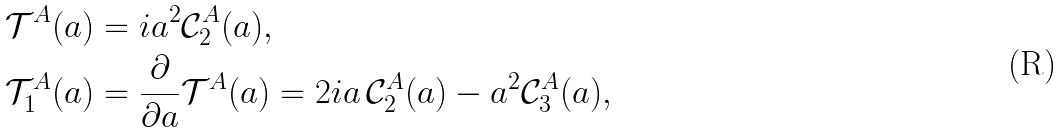Convert formula to latex. <formula><loc_0><loc_0><loc_500><loc_500>\mathcal { T } ^ { A } ( a ) & = i a ^ { 2 } \mathcal { C } _ { 2 } ^ { A } ( a ) , \\ \mathcal { T } ^ { A } _ { 1 } ( a ) & = \frac { \partial } { \partial a } \mathcal { T } ^ { A } ( a ) = 2 i a \, \mathcal { C } _ { 2 } ^ { A } ( a ) - a ^ { 2 } \mathcal { C } _ { 3 } ^ { A } ( a ) ,</formula> 